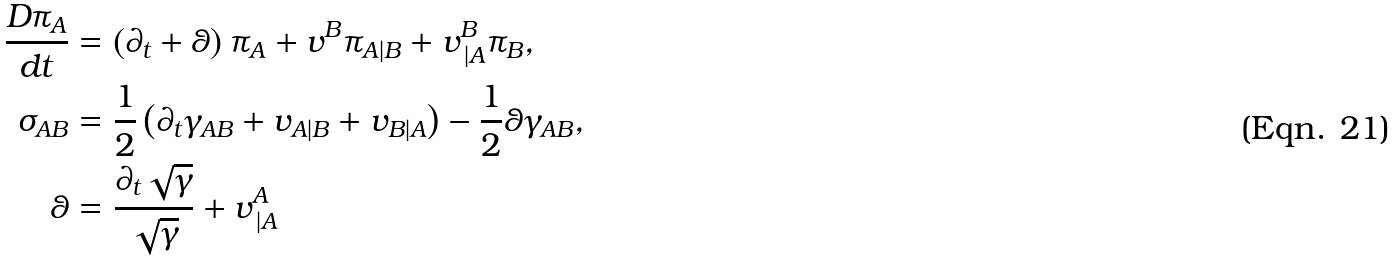<formula> <loc_0><loc_0><loc_500><loc_500>\frac { D \pi _ { A } } { d t } & = \left ( \partial _ { t } + \theta \right ) \pi _ { A } + v ^ { B } \pi _ { A | B } + v _ { \, | A } ^ { B } \pi _ { B } , \\ \sigma _ { A B } & = \frac { 1 } { 2 } \left ( \partial _ { t } \gamma _ { A B } + v _ { A | B } + v _ { B | A } \right ) - \frac { 1 } { 2 } \theta \gamma _ { A B } , \\ \theta & = \frac { \partial _ { t } \sqrt { \gamma } } { \sqrt { \gamma } } + v _ { \, | A } ^ { A }</formula> 